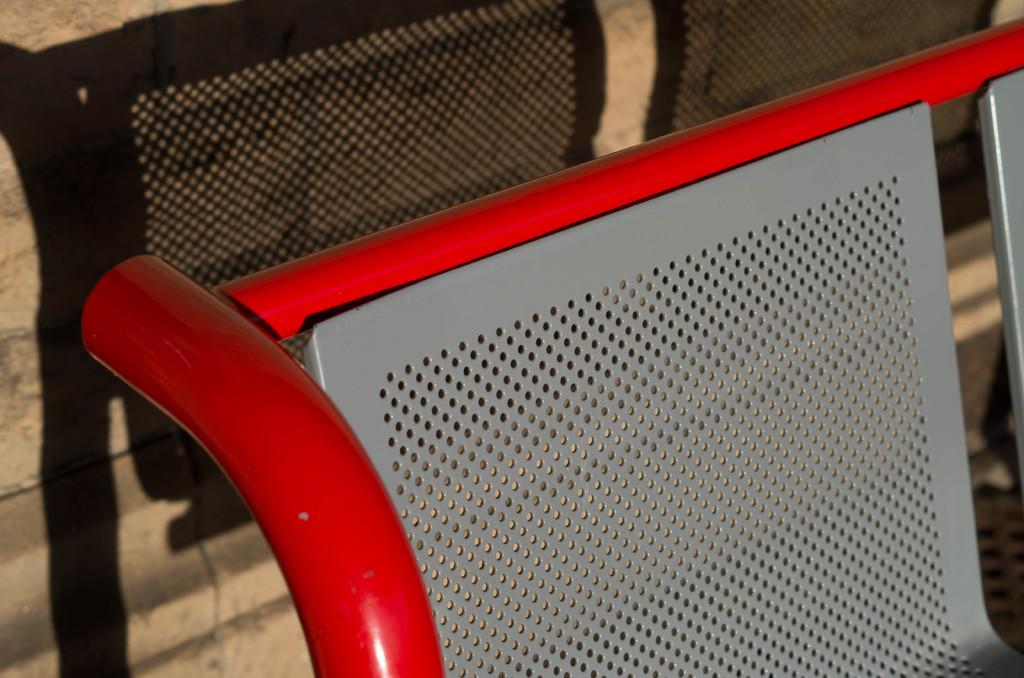What type of chair is in the picture? There is an iron chair in the picture. What colors are used for the chair? The chair is in grey and red colors. What can be seen in the background of the image? There is a wall made of stones in the background. Can you describe any additional details about the chair in the image? The shadow of the chair is visible in the image. How many people are in the crowd surrounding the chair in the image? There is no crowd present in the image; it only features the iron chair and the stone wall in the background. What type of gun is resting on the arm of the chair in the image? There is no gun present in the image; it only features the iron chair and the stone wall in the background. 